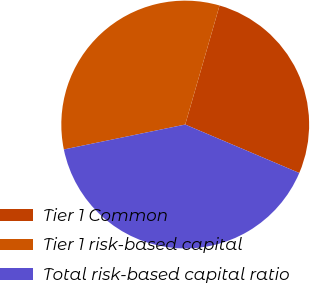<chart> <loc_0><loc_0><loc_500><loc_500><pie_chart><fcel>Tier 1 Common<fcel>Tier 1 risk-based capital<fcel>Total risk-based capital ratio<nl><fcel>26.92%<fcel>32.69%<fcel>40.38%<nl></chart> 